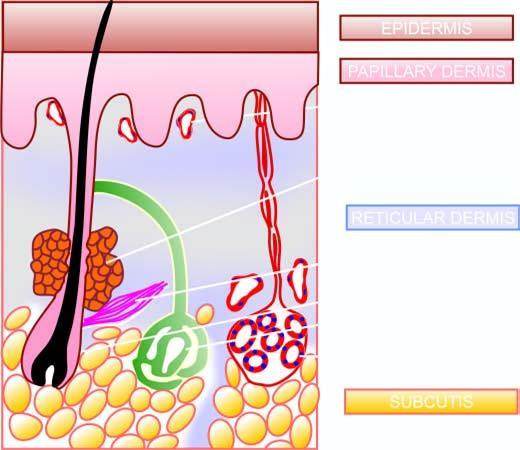what is identified in a section of the normal skin?
Answer the question using a single word or phrase. Main structures 